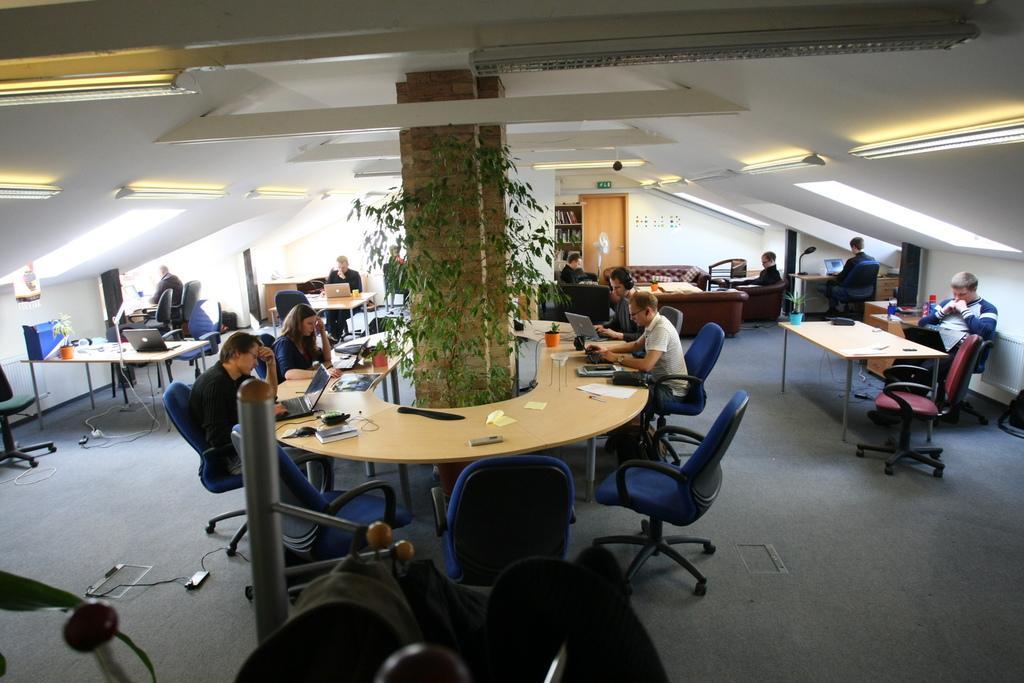In one or two sentences, can you explain what this image depicts? There rae so many people sitting in chairs around the table and there is a pillar in middle with climbers around it. And there is a sofa and bookshelf. 